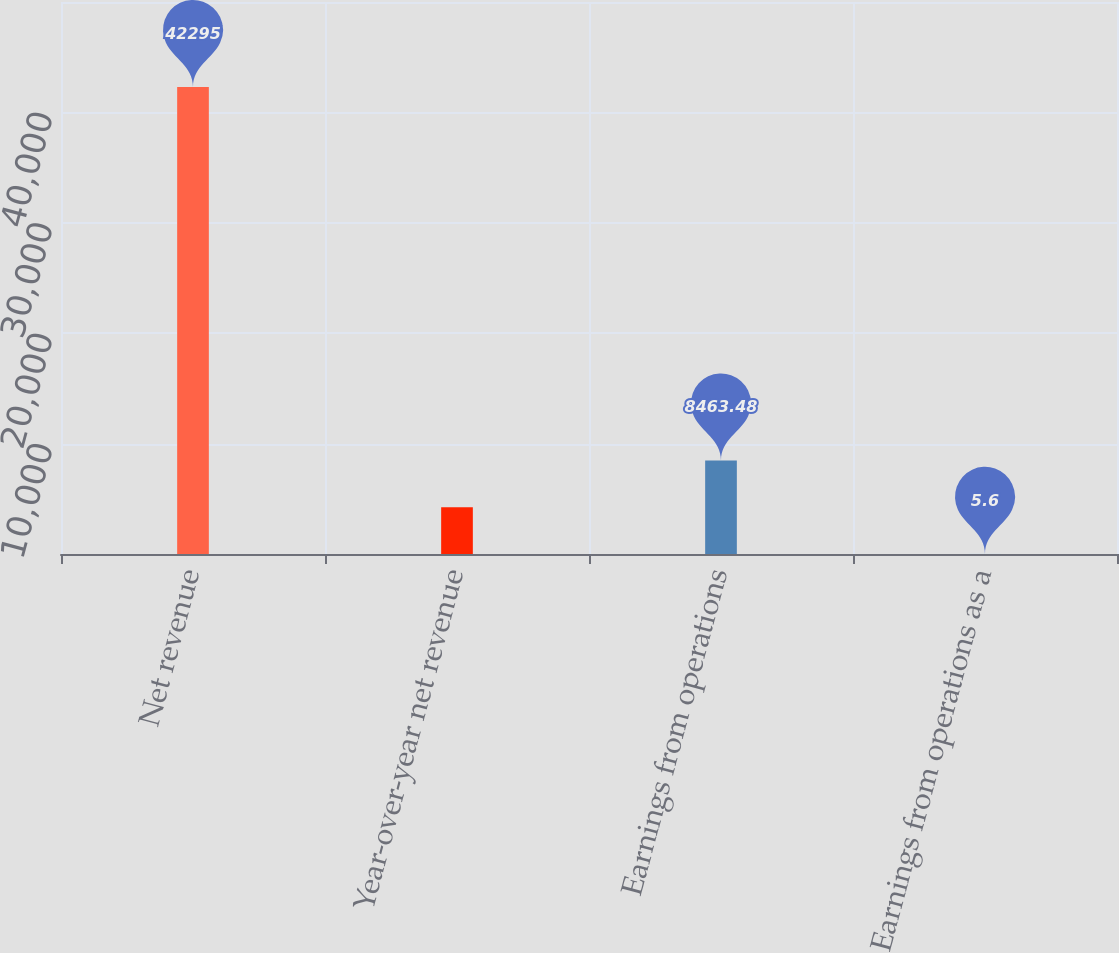Convert chart to OTSL. <chart><loc_0><loc_0><loc_500><loc_500><bar_chart><fcel>Net revenue<fcel>Year-over-year net revenue<fcel>Earnings from operations<fcel>Earnings from operations as a<nl><fcel>42295<fcel>4234.54<fcel>8463.48<fcel>5.6<nl></chart> 